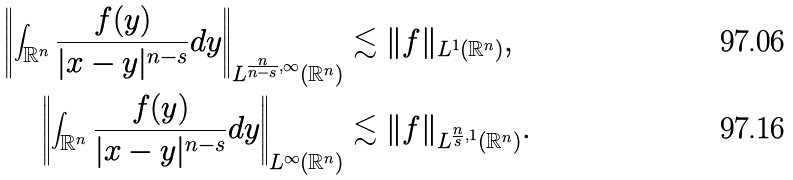Convert formula to latex. <formula><loc_0><loc_0><loc_500><loc_500>\left \| \int _ { \mathbb { R } ^ { n } } \frac { f ( y ) } { | x - y | ^ { n - s } } d y \right \| _ { L ^ { \frac { n } { n - s } , \infty } ( \mathbb { R } ^ { n } ) } & \lesssim \| f \| _ { L ^ { 1 } ( \mathbb { R } ^ { n } ) } , \\ \left \| \int _ { \mathbb { R } ^ { n } } \frac { f ( y ) } { | x - y | ^ { n - s } } d y \right \| _ { L ^ { \infty } ( \mathbb { R } ^ { n } ) } & \lesssim \| f \| _ { L ^ { \frac { n } { s } , 1 } ( \mathbb { R } ^ { n } ) } .</formula> 